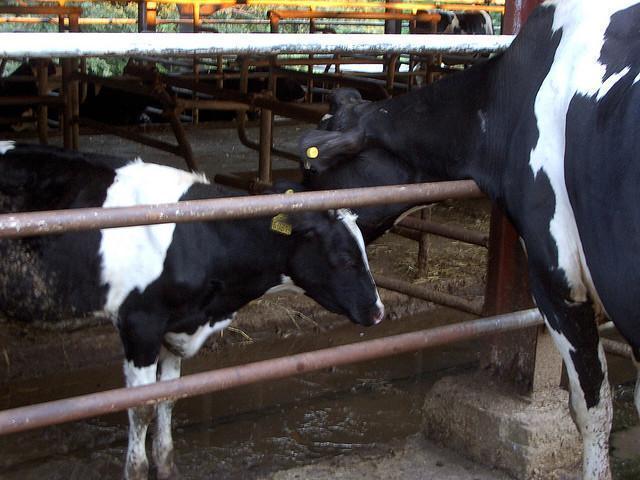Why is the mother cow in a different pen than her calf?
Choose the right answer from the provided options to respond to the question.
Options: Space restrictions, safety, feeding, cruelty. Safety. 